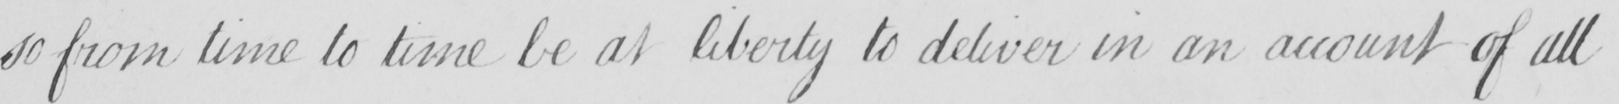What is written in this line of handwriting? so from time to time be at liberty to deliver in an account of all 